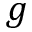Convert formula to latex. <formula><loc_0><loc_0><loc_500><loc_500>g</formula> 